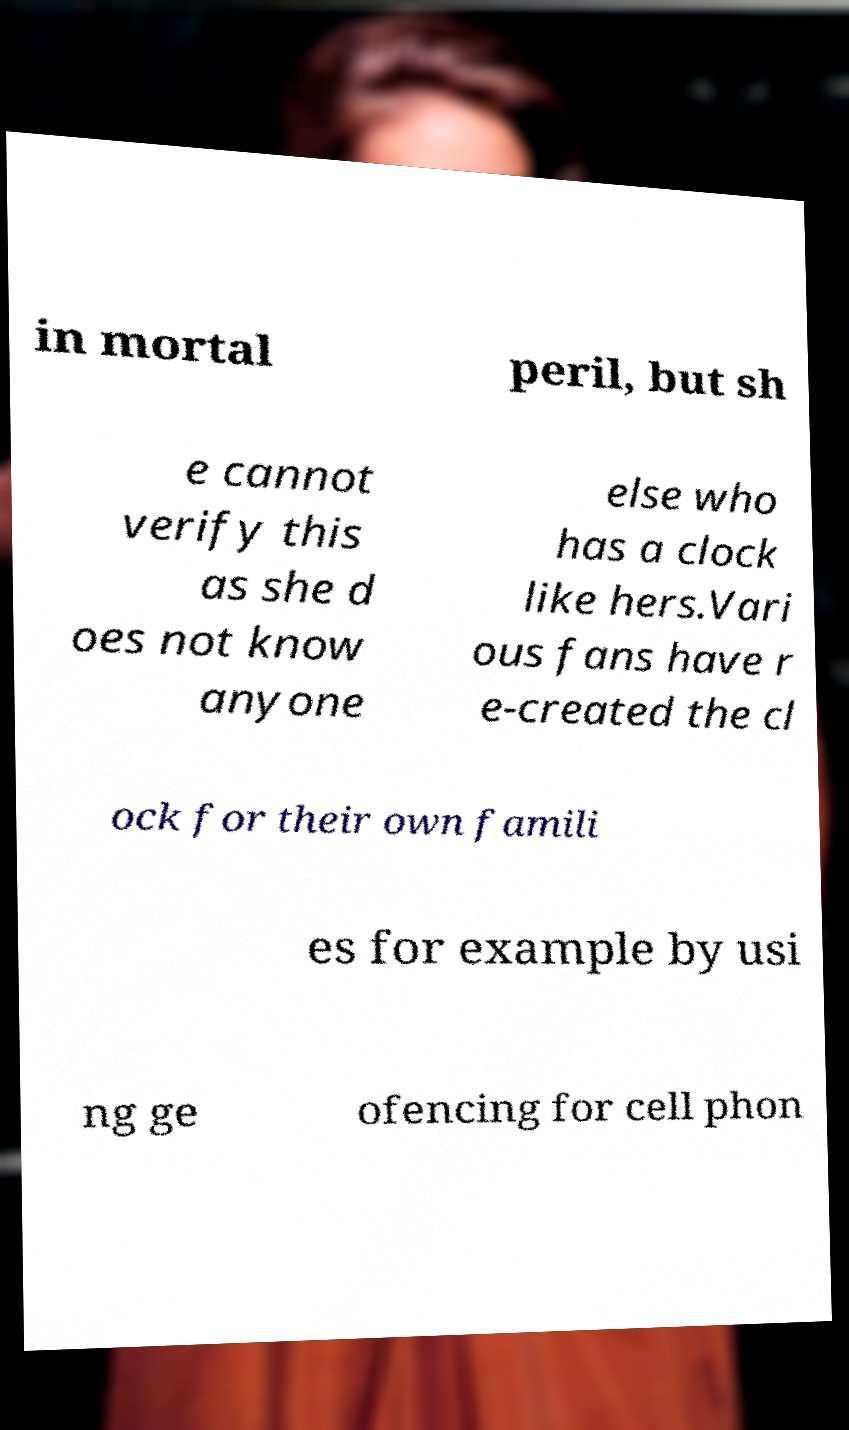For documentation purposes, I need the text within this image transcribed. Could you provide that? in mortal peril, but sh e cannot verify this as she d oes not know anyone else who has a clock like hers.Vari ous fans have r e-created the cl ock for their own famili es for example by usi ng ge ofencing for cell phon 